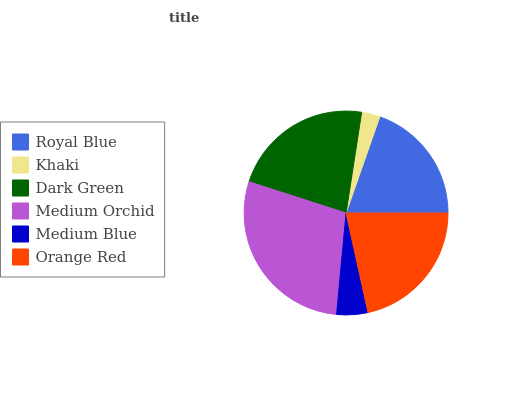Is Khaki the minimum?
Answer yes or no. Yes. Is Medium Orchid the maximum?
Answer yes or no. Yes. Is Dark Green the minimum?
Answer yes or no. No. Is Dark Green the maximum?
Answer yes or no. No. Is Dark Green greater than Khaki?
Answer yes or no. Yes. Is Khaki less than Dark Green?
Answer yes or no. Yes. Is Khaki greater than Dark Green?
Answer yes or no. No. Is Dark Green less than Khaki?
Answer yes or no. No. Is Orange Red the high median?
Answer yes or no. Yes. Is Royal Blue the low median?
Answer yes or no. Yes. Is Dark Green the high median?
Answer yes or no. No. Is Khaki the low median?
Answer yes or no. No. 